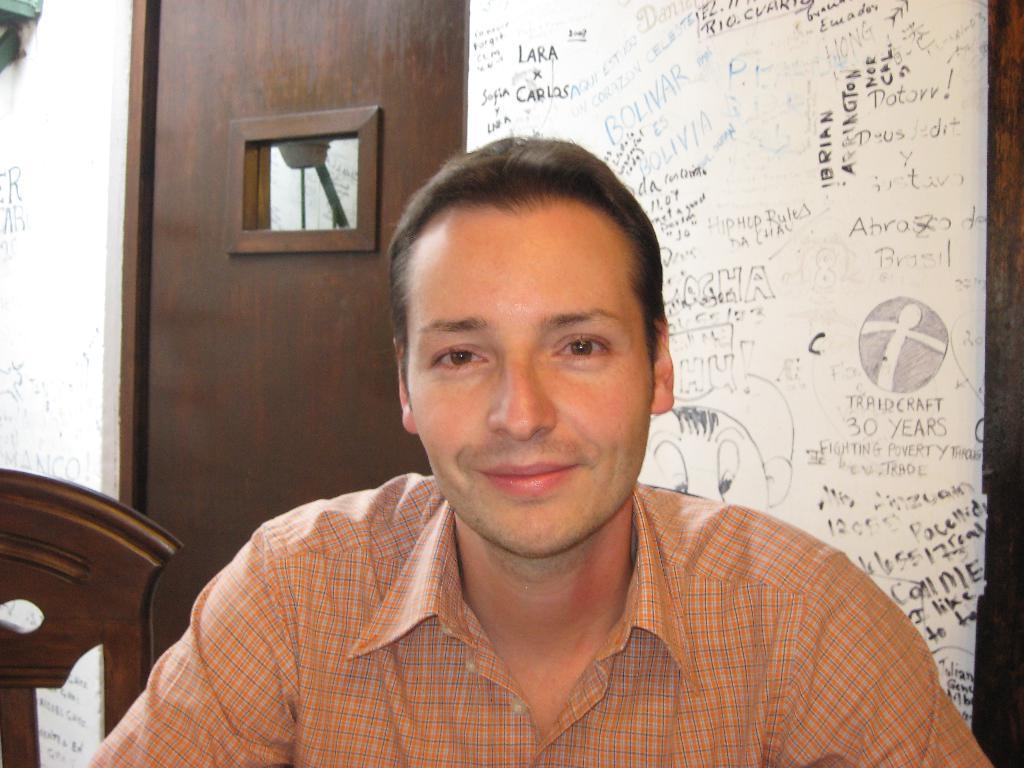Can you describe this image briefly? In this image we can see a person. On the left side of the image there is an object. In the background of the image there is a door, wall and something is written on the wall. 